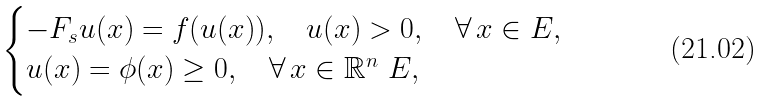Convert formula to latex. <formula><loc_0><loc_0><loc_500><loc_500>\begin{cases} - F _ { s } u ( x ) = f ( u ( x ) ) , \quad u ( x ) > 0 , \quad \forall \, x \in E , \\ u ( x ) = \phi ( x ) \geq 0 , \quad \forall \, x \in \mathbb { R } ^ { n } \ E , \end{cases}</formula> 